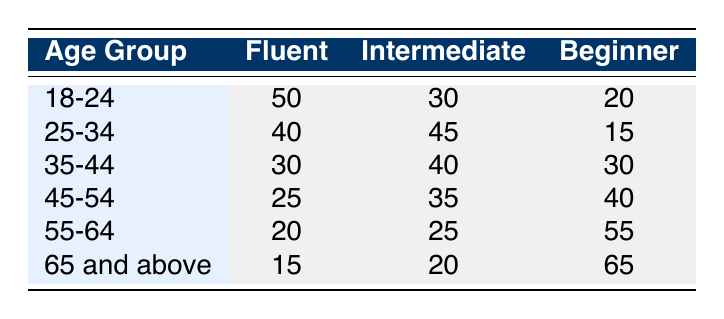What is the frequency of Greek diaspora members aged 25-34 who are Fluent? In the table, under the age group 25-34, the proficiency level "Fluent" has a frequency of 40.
Answer: 40 What is the total frequency of Beginner proficiency across all age groups? To find the total frequency of Beginner proficiency, we add the frequencies for the Beginner column: 20 (18-24) + 15 (25-34) + 30 (35-44) + 40 (45-54) + 55 (55-64) + 65 (65 and above) = 235.
Answer: 235 Is there an age group with more Intermediate members than Fluent members? Yes, by comparing the frequencies, the 25-34 age group (45 Intermediate vs. 40 Fluent) and the 35-44 age group (40 Intermediate vs. 30 Fluent) both have more Intermediate members than Fluent members.
Answer: Yes What is the average frequency of Fluent proficiency across all age groups? To calculate the average frequency of Fluent proficiency, we sum the frequencies for Fluent: 50 (18-24) + 40 (25-34) + 30 (35-44) + 25 (45-54) + 20 (55-64) + 15 (65 and above) = 180. There are 6 age groups, so the average is 180/6 = 30.
Answer: 30 Which age group has the highest frequency of Beginner proficiency? The age group with the highest frequency of Beginner proficiency is 65 and above, which has a frequency of 65.
Answer: 65 and above What is the difference in frequency between the Fluent and Intermediate proficiency for the age group 45-54? In the age group 45-54, the frequencies are 25 for Fluent and 35 for Intermediate. The difference is 35 - 25 = 10.
Answer: 10 What is the total frequency of Fluent members in the 55-64 age group? In the age group 55-64, the frequency for Fluent is 20.
Answer: 20 Do any age groups have equal frequencies for different proficiency levels? No age group has equal frequencies for different proficiency levels, as all values in each row are distinct for each proficiency type.
Answer: No 